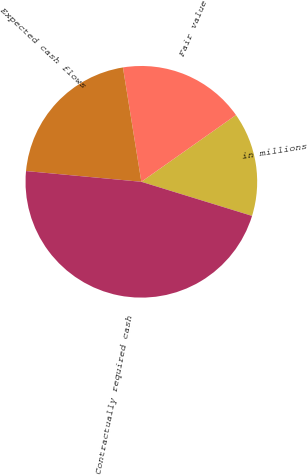Convert chart to OTSL. <chart><loc_0><loc_0><loc_500><loc_500><pie_chart><fcel>in millions<fcel>Fair value<fcel>Expected cash flows<fcel>Contractually required cash<nl><fcel>14.54%<fcel>17.76%<fcel>20.98%<fcel>46.72%<nl></chart> 